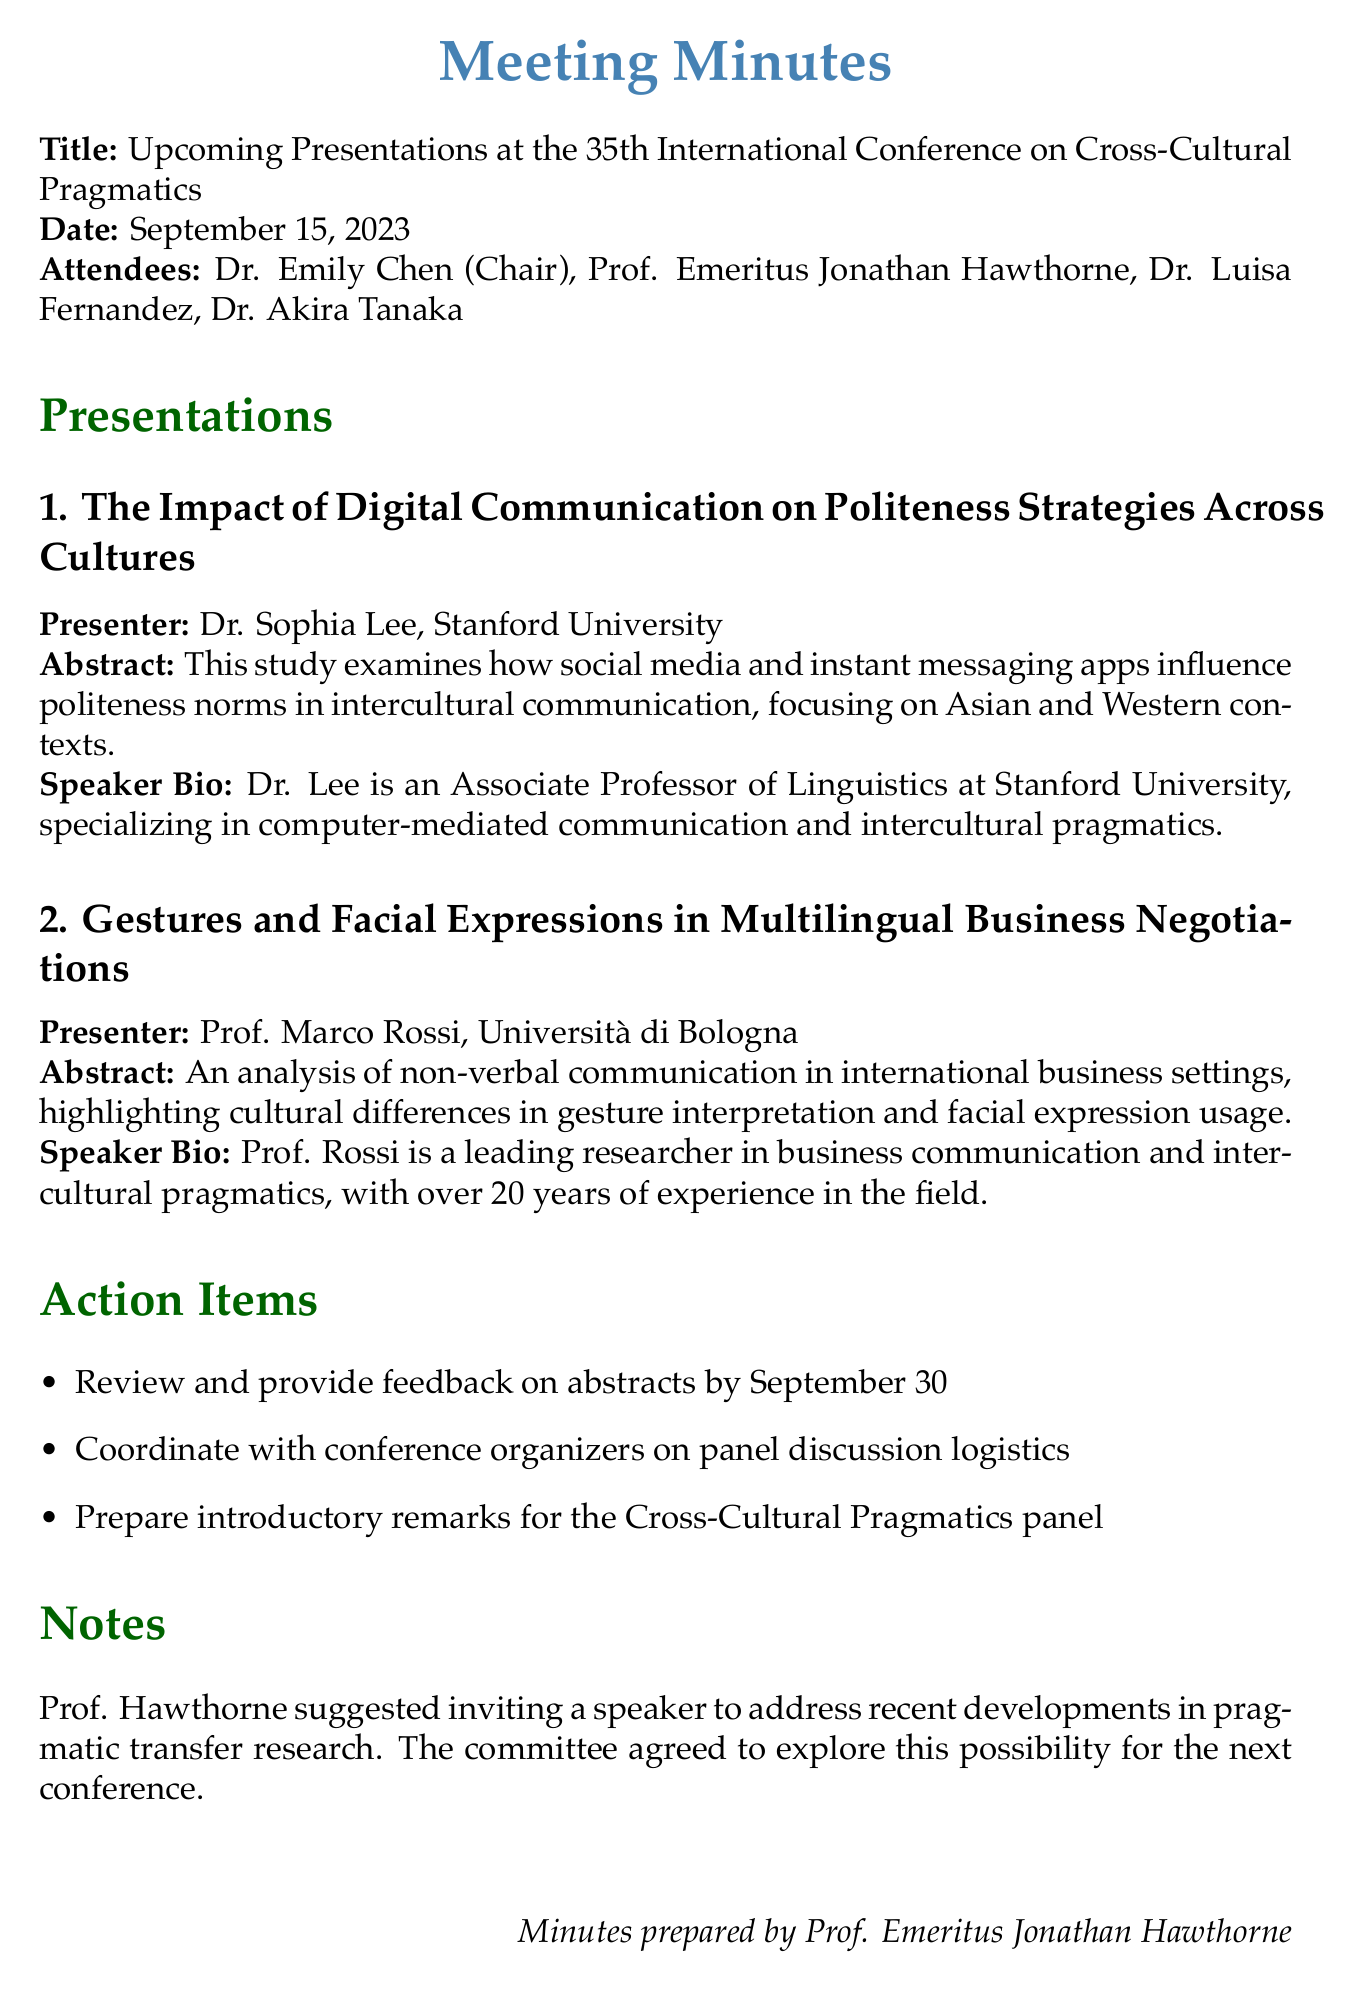What is the meeting title? The meeting title is provided at the beginning of the document.
Answer: Upcoming Presentations at the 35th International Conference on Cross-Cultural Pragmatics Who is the presenter of the first presentation? The presenter for each presentation is listed under the presentation title.
Answer: Dr. Sophia Lee, Stanford University What is the abstract of the second presentation? The abstracts of the presentations provide a summary of the research topics being presented.
Answer: An analysis of non-verbal communication in international business settings, highlighting cultural differences in gesture interpretation and facial expression usage What is the deadline for feedback on abstracts? The action items section includes deadlines and tasks for attendees.
Answer: September 30 Who suggested inviting a speaker for recent developments in pragmatic transfer research? The notes at the end of the document outline contributions from attendees.
Answer: Prof. Hawthorne 